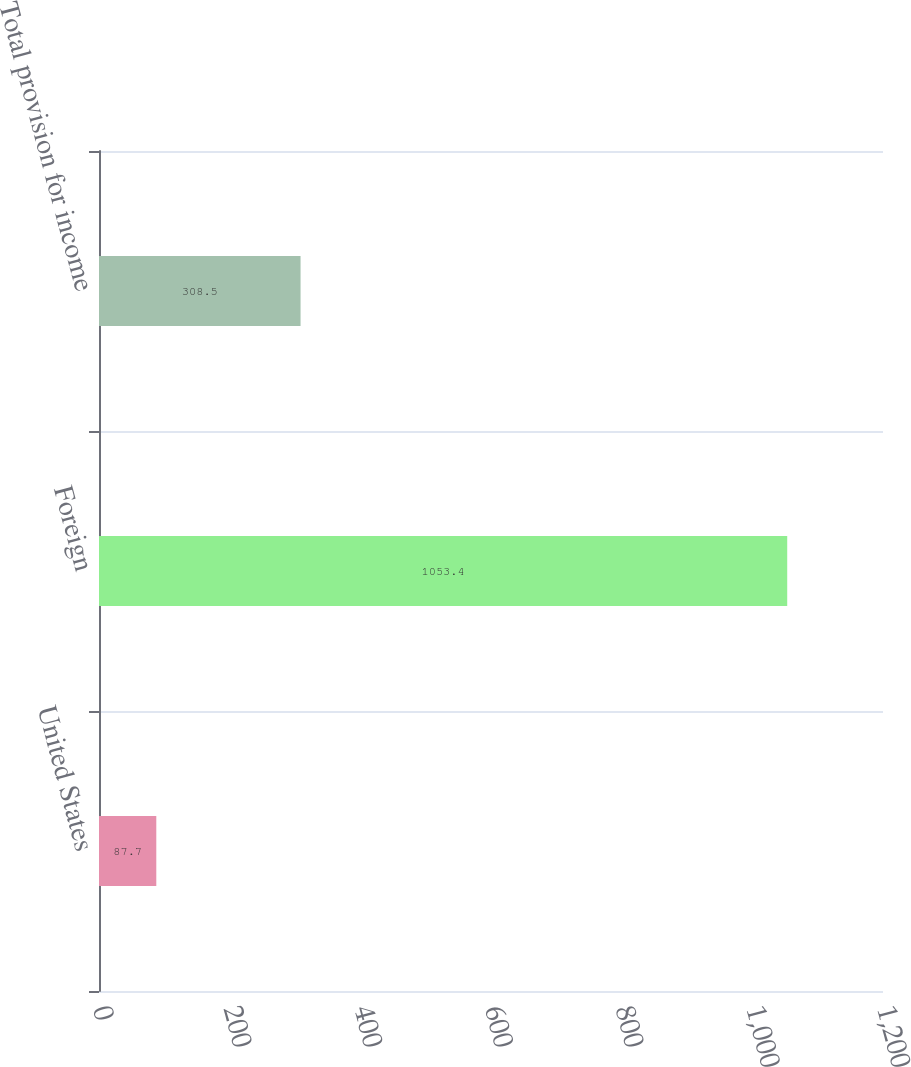Convert chart to OTSL. <chart><loc_0><loc_0><loc_500><loc_500><bar_chart><fcel>United States<fcel>Foreign<fcel>Total provision for income<nl><fcel>87.7<fcel>1053.4<fcel>308.5<nl></chart> 